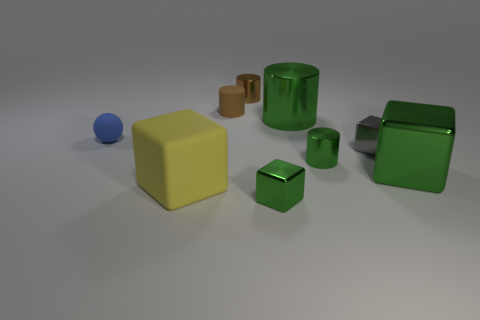Are there any gray blocks of the same size as the rubber cylinder?
Offer a terse response. Yes. Is the small brown metallic object the same shape as the small brown rubber thing?
Your response must be concise. Yes. Are there any large cylinders behind the brown cylinder that is behind the tiny cylinder that is on the left side of the tiny brown metal cylinder?
Give a very brief answer. No. What number of other things are there of the same color as the rubber cylinder?
Provide a short and direct response. 1. There is a object behind the tiny brown matte cylinder; does it have the same size as the matte cylinder that is behind the tiny green cube?
Your answer should be very brief. Yes. Are there the same number of green cubes that are on the left side of the yellow block and small brown cylinders left of the gray metallic block?
Give a very brief answer. No. Is the size of the blue rubber sphere the same as the green thing behind the small green metal cylinder?
Offer a terse response. No. There is a big object to the left of the object that is in front of the large yellow thing; what is its material?
Your response must be concise. Rubber. Is the number of big green metal things behind the small gray shiny block the same as the number of green cubes?
Ensure brevity in your answer.  No. There is a cube that is both left of the big green metal cylinder and on the right side of the big matte cube; what is its size?
Ensure brevity in your answer.  Small. 